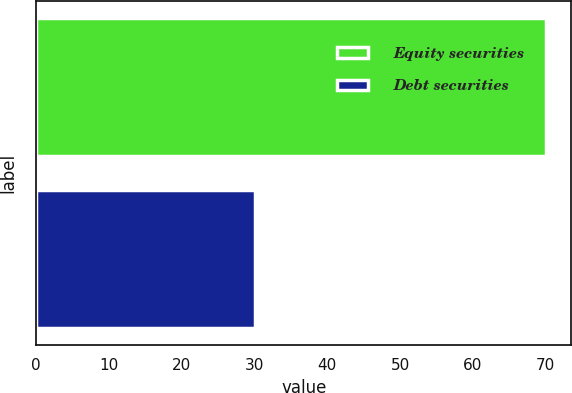Convert chart. <chart><loc_0><loc_0><loc_500><loc_500><bar_chart><fcel>Equity securities<fcel>Debt securities<nl><fcel>70<fcel>30<nl></chart> 